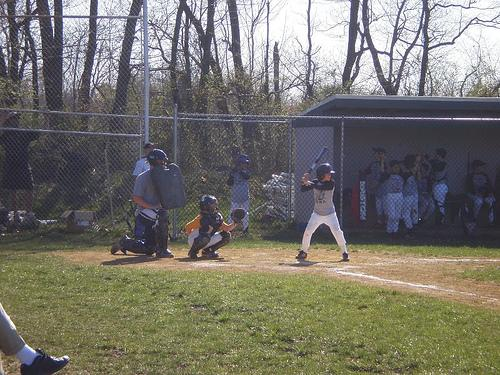Provide a brief description of the image's overall atmosphere and sentiment. The image depicts a lively and energetic scene of young baseball players engaged in a game, with a sense of excitement and competition. Analyze and describe the interaction between the boy holding a bat and the catcher. The boy holding the bat is preparing to swing at the incoming pitch, while the catcher is waiting to receive the pitch or catch a missed hit, showcasing the competitive tension between them. Determine the type of building in the background of the image. The building in the background is a long grey dugout building. What type of clothing is worn by the person leaning on the fence? The person leaning on the fence is wearing dark clothes. Please count the number of black baseball helmets visible in the image. There are four black baseball helmets present in the image. Which object is the largest in the image? The green grassy baseball field is the largest object in the image. Describe the overall quality of the image, in terms of clarity and composition. The image is clear and well-composed, with precise object detection, well-defined bounding boxes, and capturing various elements of a baseball game. What color are the pants of the baseball players? The pants of the baseball players are white. Explain the function of the high fence behind home plate in the context of a baseball game. The high fence behind home plate is designed to protect spectators and other areas outside the field from getting hit by foul balls or stray pitches. Identify the primary activity taking place in the image. Young baseball players are participating in a game, with a batter at bat and a catcher waiting for the pitch. How is the overall mood of the scene depicted in the image?  Competitive and energetic. What is the quality of the image? High. Could you please point out the red soccer ball located near the fence? It must be misplaced during the game. There is no red soccer ball mentioned in the image. This instruction is misleading because it introduces a non-existent object, uses a polite interrogative tone, and suggests an explanation for its presence. Determine the objects owned by the boy holding a bat. Black baseball bat, white pants, and black baseball cleats. Segment the objects on the green grassy baseball field. The green grassy baseball field is at X:0 Y:223 Width:499 Height:499. Describe the interaction between the boy holding a bat and the young catcher waiting for pitch. The boy holding a bat is preparing to hit the ball while the young catcher is waiting to catch the pitch. Find the area in the image that contains a boy holding a bat. X:291 Y:140 Width:63 Height:63 A blue cap is dropped on the green grassy field near the metal fence, probably by a player during practice. No, it's not mentioned in the image. Where did they place the orange traffic cone as a temporary base marker? I can't seem to find it in the image. There is no orange traffic cone mentioned in the image. This instruction is misleading because it uses an interrogative sentence that implies the presence of an object in the scene which is not there, making the reader question their perception of the image. Can you find the white baseball stuck in the high fence behind home plate? It must have been a foul ball. There is no white baseball mentioned in the image. This instruction is misleading because it introduces a non-existent object, uses an interrogative tone and suggests a narrative for its presence, causing the reader to actively search for something that's not there. Notice the girl standing near the dugout building cheering for her team. There is no girl mentioned in the image. This instruction is misleading because it uses a declarative sentence to assert the existence of a non-existent object, making the reader think they have missed something in the image. Identify if there are any anomalies in the image. There are no significant anomalies in the image. How many baseball helmets are present in the image? Four. Identify objects and their locations in the image. black baseball bat(294,141,31,31), black baseball helmets(315,161,19,19; 199,195,18,18; 146,147,17,17; 236,153,10,10), brown baseball glove(232,207,15,15), black baseball cleats(294,247,14,14; 340,251,11,11; 186,251,9,9; 202,249,22,22), white pants(259,194,124,124; 239,211,128,128), boy's head(318,157,21,21), boy's arm(309,175,27,27), boy's leg(326,213,25,25), black catchers mitt(228,202,24,24), black shoe(20,342,57,57), white sock(13,337,29,29), boy holding a bat(291,140,63,63), white line on dirt(334,262,163,163), boys cheering(362,138,94,94; 363,162,81,81; 382,144,51,51; 389,115,72,72), young baseball player at bat(286,143,74,74), young catcher waiting for pitch(174,189,73,73), kneeling umpire waiting for pitch(113,141,75,75), man in dark clothes leaning on fence(0,98,52,52), long gray dugout building(283,89,215,215), high fence behind home plate(2,0,164,164), metal fence around baseball field(151,103,345,345), green grassy baseball field(0,223,499,499), infield dirt on baseball field(48,239,450,450), long chalk lines on baseball field(318,246,179,179) Describe the main sentiment portrayed by the boys cheering. Excitement and support. Are there any instances of text or numbers within the image? No, there are no instances of text or numbers. What color is the baseball cleat of the batter? Black. Find the hidden water bottle behind the umpire and bring it to the boy holding the bat. There is no water bottle mentioned in the image. This instruction is misleading because it implies a hidden object using a declarative sentence and gives an action to complete involving the non-existent object. Identify the position of the white pants in the image. X:259 Y:194 Width:124 Height:124, X:239 Y:211 Width:128 Height:128 Analyze and describe the general features of the infield dirt on the baseball field. The infield dirt is a large area with a white line and has dimensions X:48 Y:239 Width:450 Height:450. What type of clothing does the man leaning on the fence wear? Dark clothes. Is the image a positive or negative depiction of sportsmanship? Positive. Where is the black catchers mitt located in the image? X:228 Y:202 Width:24 Height:24 